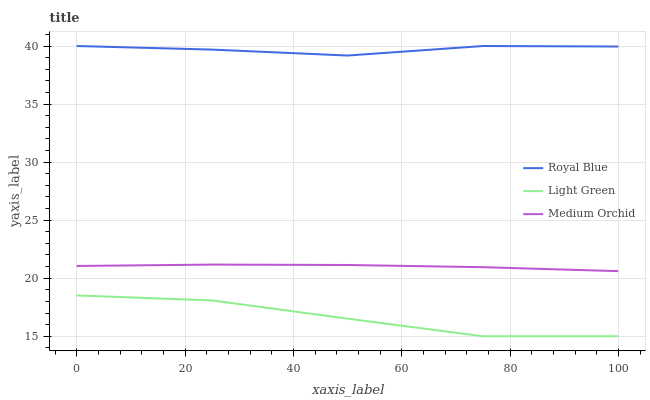Does Light Green have the minimum area under the curve?
Answer yes or no. Yes. Does Royal Blue have the maximum area under the curve?
Answer yes or no. Yes. Does Medium Orchid have the minimum area under the curve?
Answer yes or no. No. Does Medium Orchid have the maximum area under the curve?
Answer yes or no. No. Is Medium Orchid the smoothest?
Answer yes or no. Yes. Is Light Green the roughest?
Answer yes or no. Yes. Is Light Green the smoothest?
Answer yes or no. No. Is Medium Orchid the roughest?
Answer yes or no. No. Does Light Green have the lowest value?
Answer yes or no. Yes. Does Medium Orchid have the lowest value?
Answer yes or no. No. Does Royal Blue have the highest value?
Answer yes or no. Yes. Does Medium Orchid have the highest value?
Answer yes or no. No. Is Medium Orchid less than Royal Blue?
Answer yes or no. Yes. Is Royal Blue greater than Light Green?
Answer yes or no. Yes. Does Medium Orchid intersect Royal Blue?
Answer yes or no. No. 